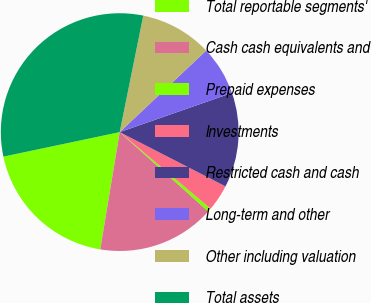Convert chart. <chart><loc_0><loc_0><loc_500><loc_500><pie_chart><fcel>Total reportable segments'<fcel>Cash cash equivalents and<fcel>Prepaid expenses<fcel>Investments<fcel>Restricted cash and cash<fcel>Long-term and other<fcel>Other including valuation<fcel>Total assets<nl><fcel>19.08%<fcel>15.99%<fcel>0.49%<fcel>3.59%<fcel>12.89%<fcel>6.69%<fcel>9.79%<fcel>31.48%<nl></chart> 